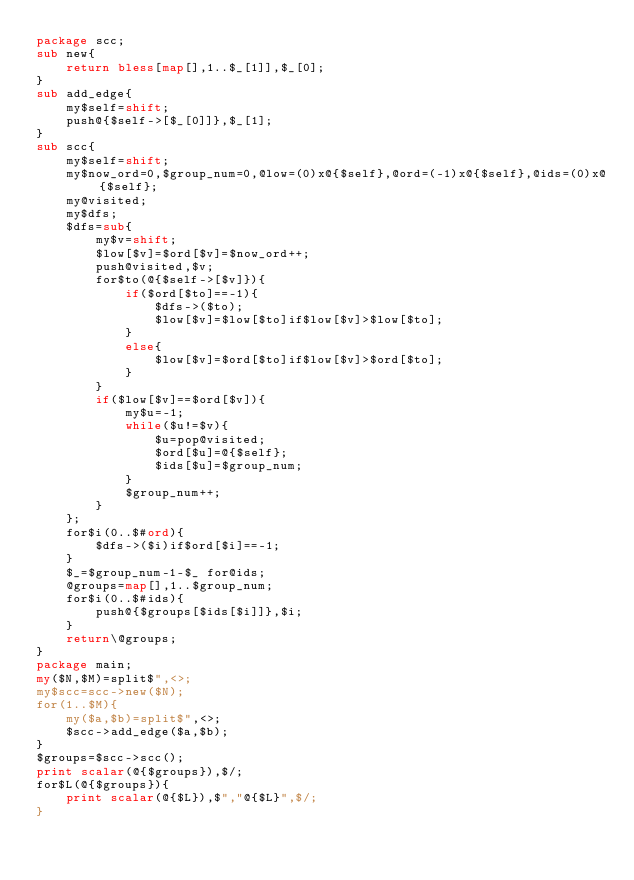<code> <loc_0><loc_0><loc_500><loc_500><_Perl_>package scc;
sub new{
	return bless[map[],1..$_[1]],$_[0];
}
sub add_edge{
	my$self=shift;
	push@{$self->[$_[0]]},$_[1];
}
sub scc{
	my$self=shift;
	my$now_ord=0,$group_num=0,@low=(0)x@{$self},@ord=(-1)x@{$self},@ids=(0)x@{$self};
	my@visited;
	my$dfs;
	$dfs=sub{
		my$v=shift;
		$low[$v]=$ord[$v]=$now_ord++;
		push@visited,$v;
		for$to(@{$self->[$v]}){
			if($ord[$to]==-1){
				$dfs->($to);
				$low[$v]=$low[$to]if$low[$v]>$low[$to];
			}
			else{
				$low[$v]=$ord[$to]if$low[$v]>$ord[$to];
			}
		}
		if($low[$v]==$ord[$v]){
			my$u=-1;
			while($u!=$v){
				$u=pop@visited;
				$ord[$u]=@{$self};
				$ids[$u]=$group_num;
			}
			$group_num++;
		}
	};
	for$i(0..$#ord){
		$dfs->($i)if$ord[$i]==-1;
	}
	$_=$group_num-1-$_ for@ids;
	@groups=map[],1..$group_num;
	for$i(0..$#ids){
		push@{$groups[$ids[$i]]},$i;
	}
	return\@groups;
}
package main;
my($N,$M)=split$",<>;
my$scc=scc->new($N);
for(1..$M){
	my($a,$b)=split$",<>;
	$scc->add_edge($a,$b);
}
$groups=$scc->scc();
print scalar(@{$groups}),$/;
for$L(@{$groups}){
	print scalar(@{$L}),$","@{$L}",$/;
}
</code> 